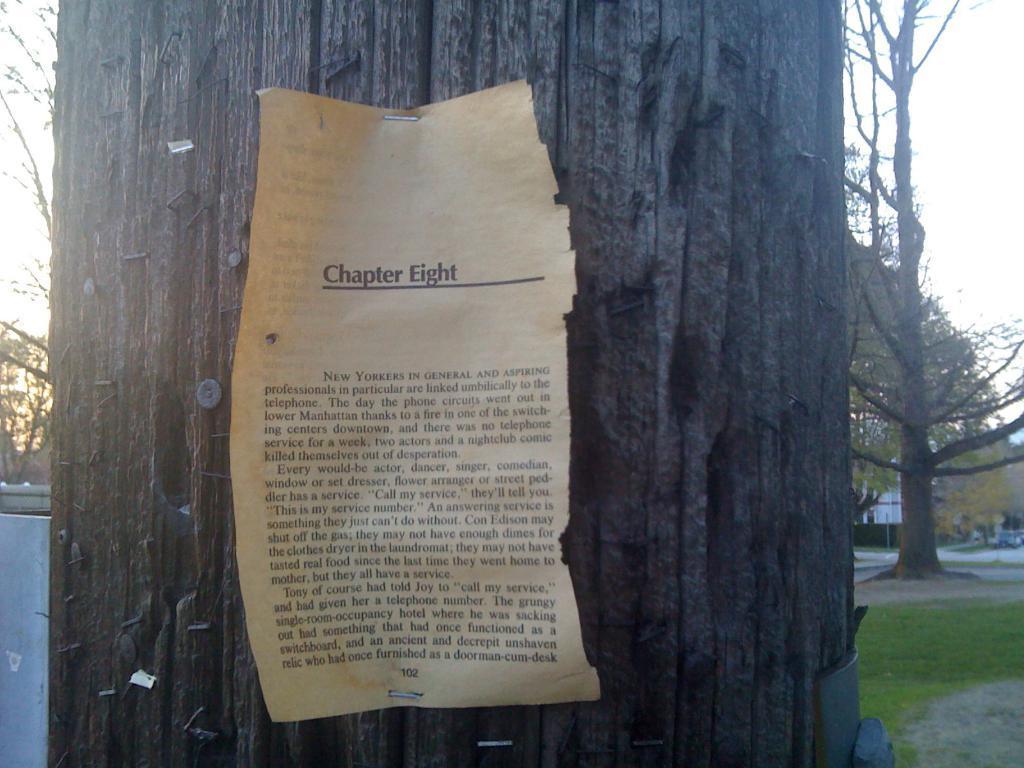Can you describe this image briefly? In this picture we can see a paper on a tree trunk, grass, car on the road, trees and in the background we can see the sky. 